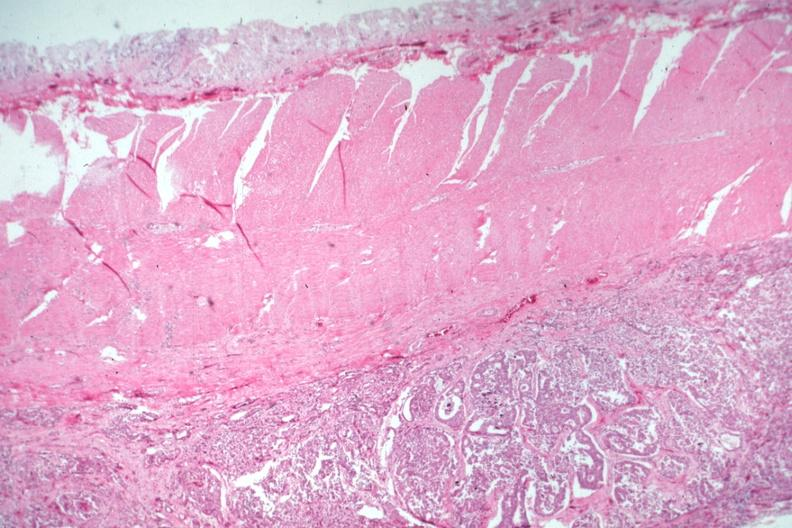does cytomegalovirus show carcinoma on peritoneal side of muscularis?
Answer the question using a single word or phrase. No 